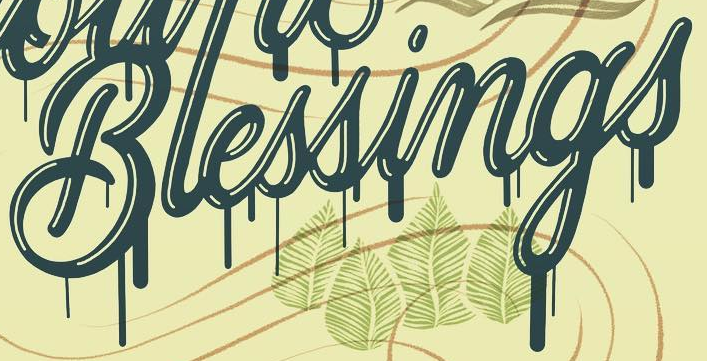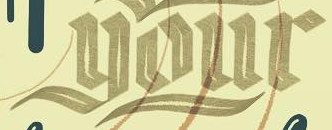What words can you see in these images in sequence, separated by a semicolon? Blessings; your 